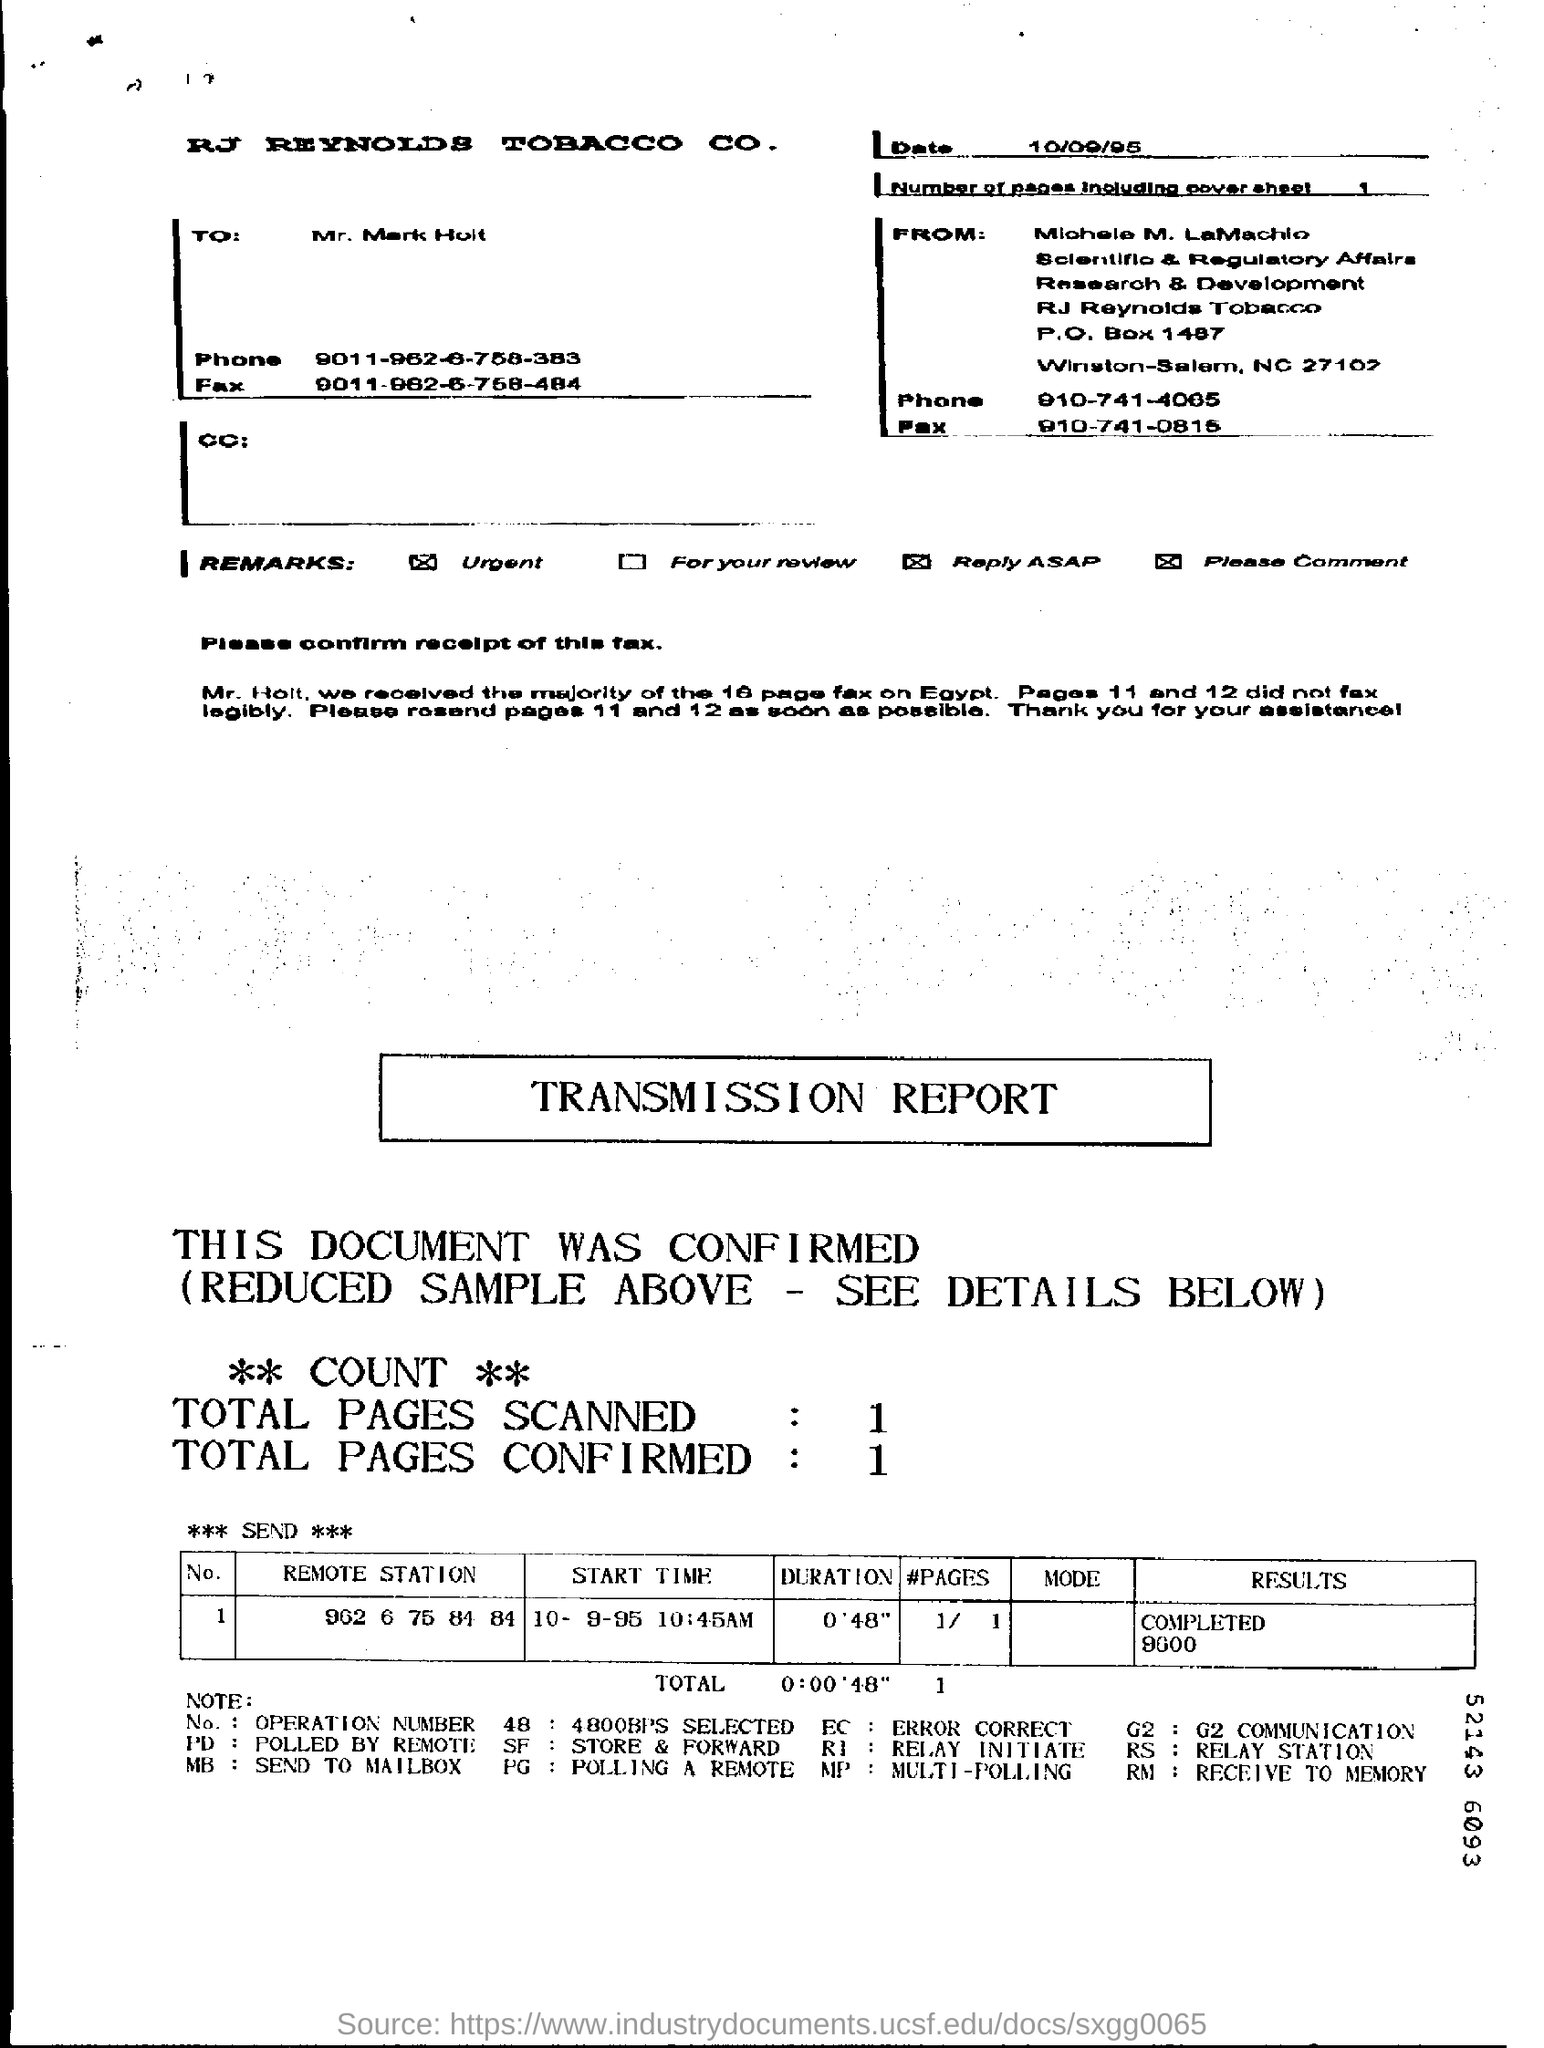Highlight a few significant elements in this photo. The date on the fax is 10/09/95. The total number of confirmed pages is 1.. What is the duration for the remote station number 902, channel 6, with a frequency of 75.84 MHz and a signal strength of 84? The duration is expected to be 048 seconds. The start time for the remote station 902 6 75 84 84 is 10:45 AM on October 9th, 1995. The total number of pages scanned is 1.. 